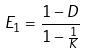Convert formula to latex. <formula><loc_0><loc_0><loc_500><loc_500>E _ { 1 } = \frac { 1 - D } { 1 - \frac { 1 } { K } }</formula> 